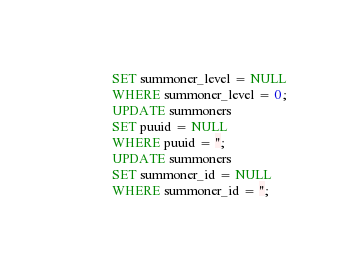Convert code to text. <code><loc_0><loc_0><loc_500><loc_500><_SQL_>SET summoner_level = NULL
WHERE summoner_level = 0;
UPDATE summoners
SET puuid = NULL
WHERE puuid = '';
UPDATE summoners
SET summoner_id = NULL
WHERE summoner_id = '';</code> 